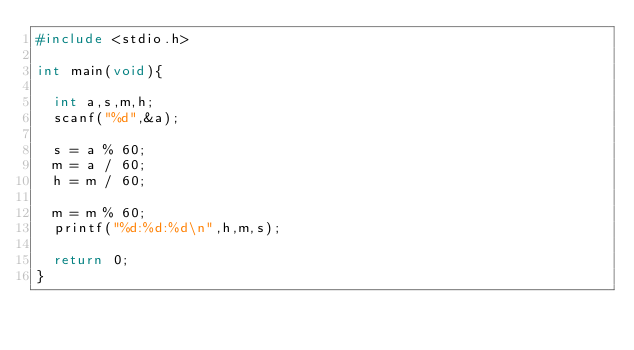<code> <loc_0><loc_0><loc_500><loc_500><_C_>#include <stdio.h>

int main(void){

  int a,s,m,h;
  scanf("%d",&a);

  s = a % 60;
  m = a / 60;
  h = m / 60;

  m = m % 60;
  printf("%d:%d:%d\n",h,m,s);

  return 0;
}</code> 